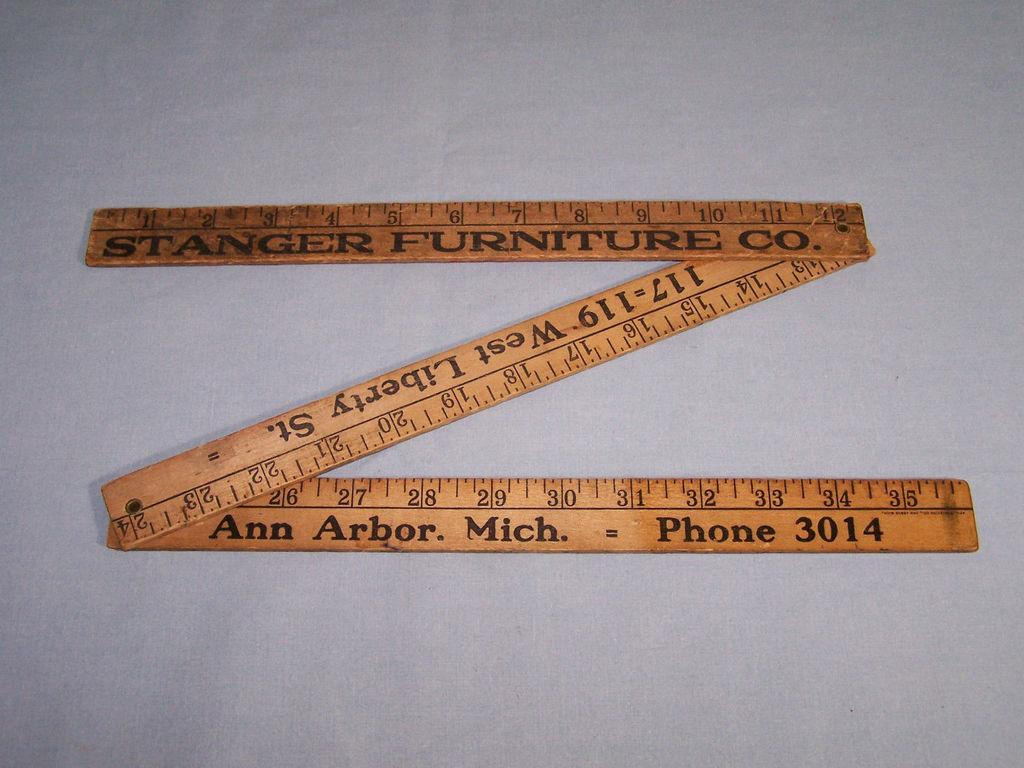<image>
Create a compact narrative representing the image presented. A folding ruler is shown, which says Stanger Furniture Co. on it. 